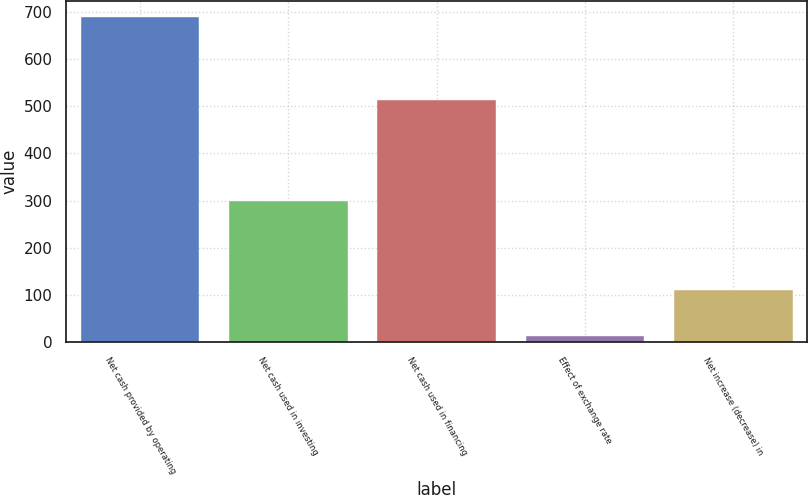<chart> <loc_0><loc_0><loc_500><loc_500><bar_chart><fcel>Net cash provided by operating<fcel>Net cash used in investing<fcel>Net cash used in financing<fcel>Effect of exchange rate<fcel>Net increase (decrease) in<nl><fcel>688.7<fcel>299.4<fcel>512.6<fcel>13.2<fcel>110.1<nl></chart> 